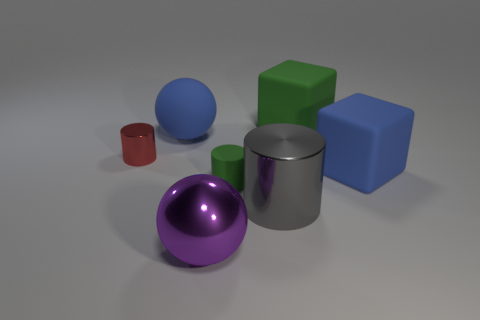What is the texture of the objects? The objects have varying textures. The purple and blue spheres, the red cylinder, and the blue cube have shiny, reflective surfaces. In contrast, the green cube and the gray cylinder have a matte finish with no reflections. Is there any pattern to the arrangement of these objects? The objects are arranged in a somewhat scattered manner without a clear pattern. However, they generally occupy the center of the image and are spaced out evenly across the surface. 